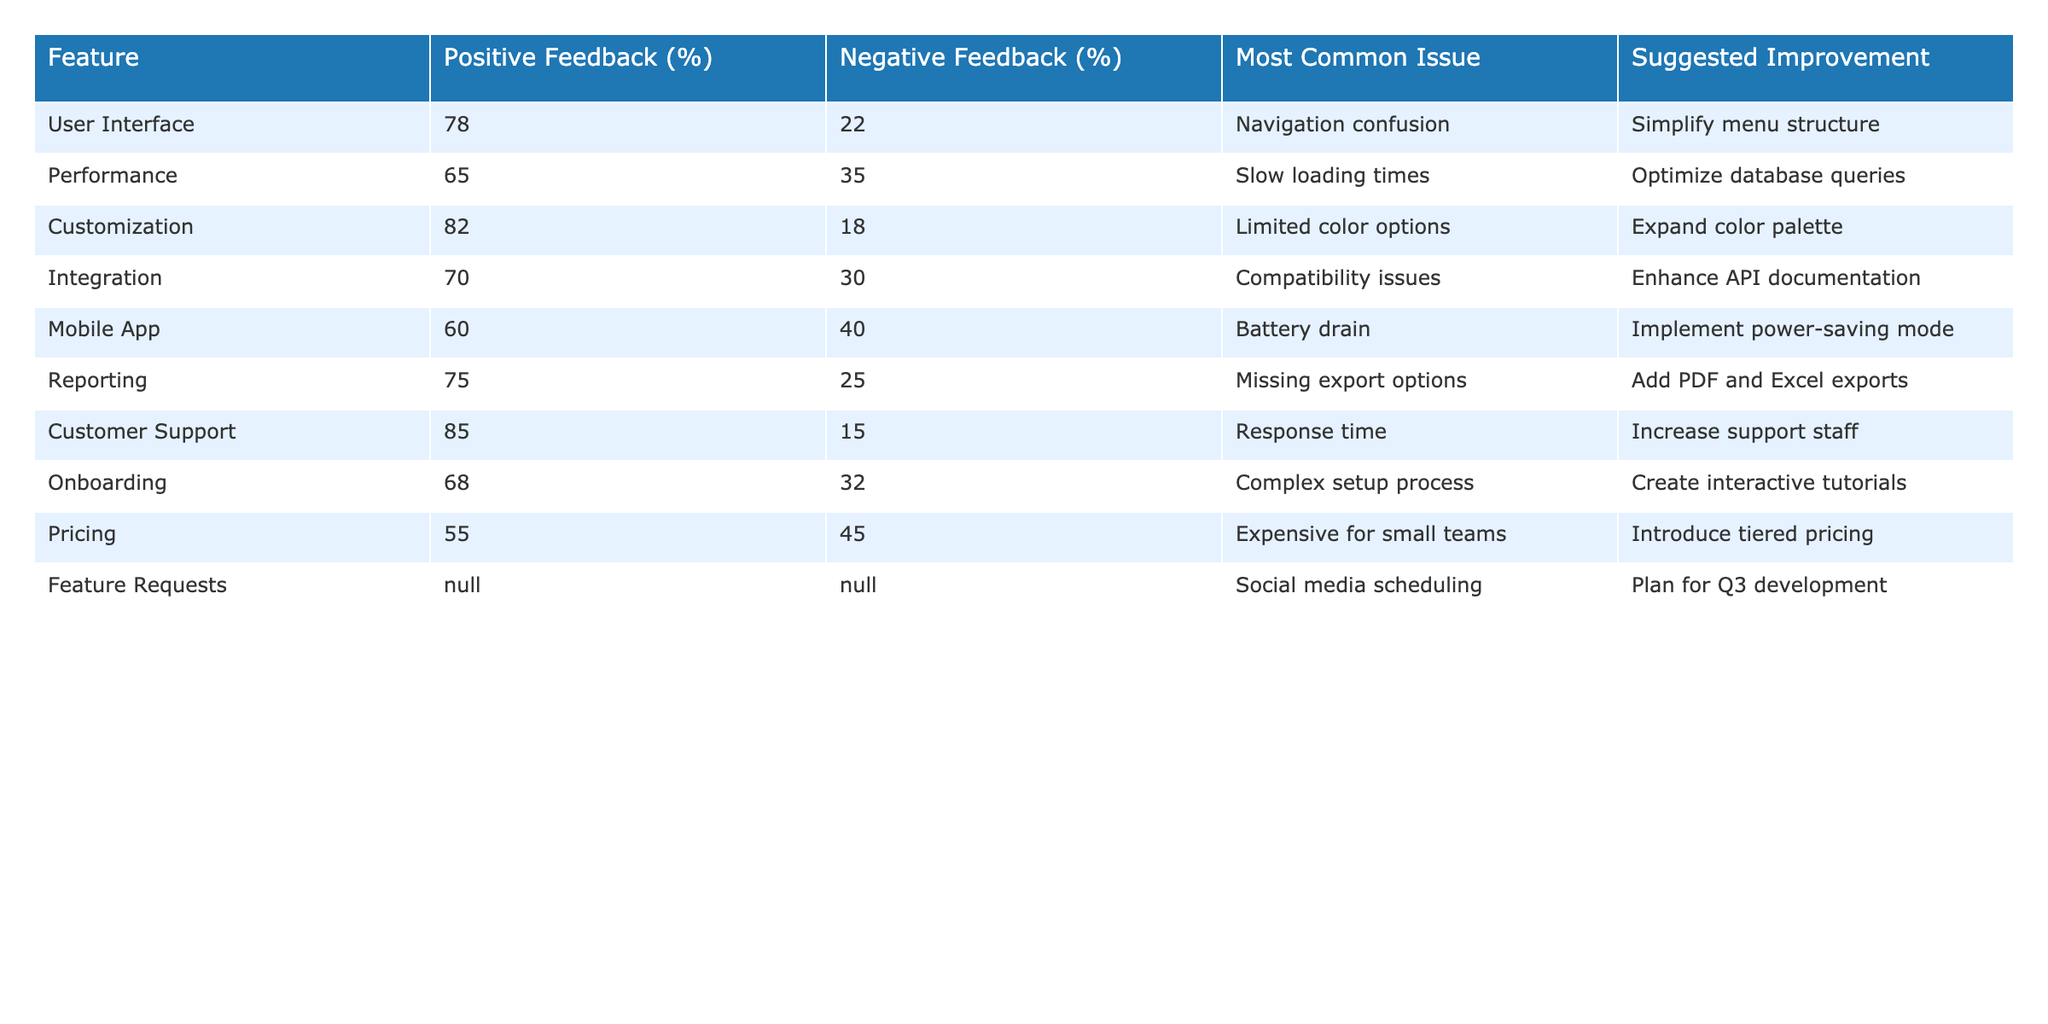What percentage of users provided positive feedback for the User Interface feature? According to the table, the Positive Feedback percentage for the User Interface feature is clearly displayed. It shows 78% positive feedback from users.
Answer: 78% What is the most common issue reported for the Mobile App feature? The table indicates that the most common issue for the Mobile App feature is battery drain.
Answer: Battery drain How many features have more than 70% positive feedback? To find the answer, we look at the Positive Feedback percentages for each feature in the table. The features with more than 70% positive feedback are User Interface (78%), Customization (82%), Reporting (75%), and Customer Support (85%). That's a total of 4 features.
Answer: 4 Is the negative feedback for the Pricing feature higher than that for the Integration feature? The negative feedback for Pricing is 45%, while for Integration, it is 30%. Since 45% is greater than 30%, the negative feedback for the Pricing feature is indeed higher.
Answer: Yes What is the average percentage of negative feedback across all features listed? To calculate the average negative feedback, we first sum the negative feedback percentages of all features: 22 + 35 + 18 + 30 + 40 + 25 + 15 + 32 + 45 = 252. There are 9 features with negative feedback, so the average is 252 / 9 = 28. Therefore, the average percentage of negative feedback across all features is 28%.
Answer: 28% 